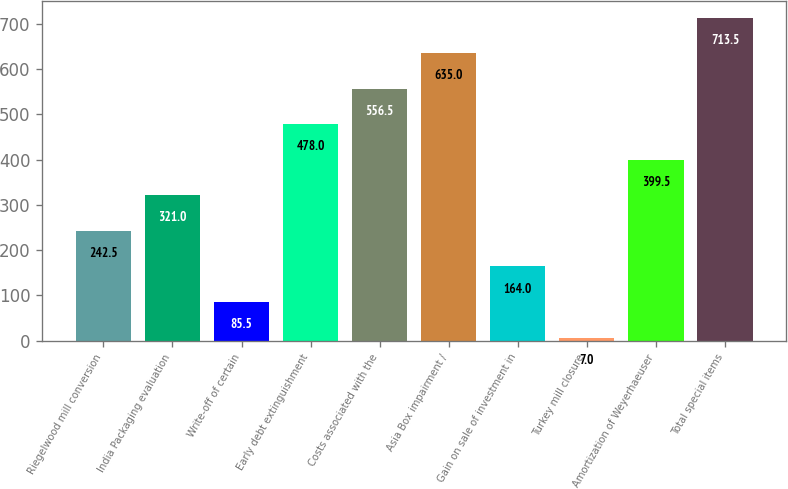Convert chart to OTSL. <chart><loc_0><loc_0><loc_500><loc_500><bar_chart><fcel>Riegelwood mill conversion<fcel>India Packaging evaluation<fcel>Write-off of certain<fcel>Early debt extinguishment<fcel>Costs associated with the<fcel>Asia Box impairment /<fcel>Gain on sale of investment in<fcel>Turkey mill closure<fcel>Amortization of Weyerhaeuser<fcel>Total special items<nl><fcel>242.5<fcel>321<fcel>85.5<fcel>478<fcel>556.5<fcel>635<fcel>164<fcel>7<fcel>399.5<fcel>713.5<nl></chart> 